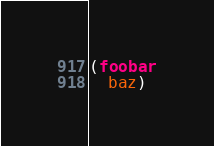<code> <loc_0><loc_0><loc_500><loc_500><_Clojure_>(foobar
  baz)
</code> 